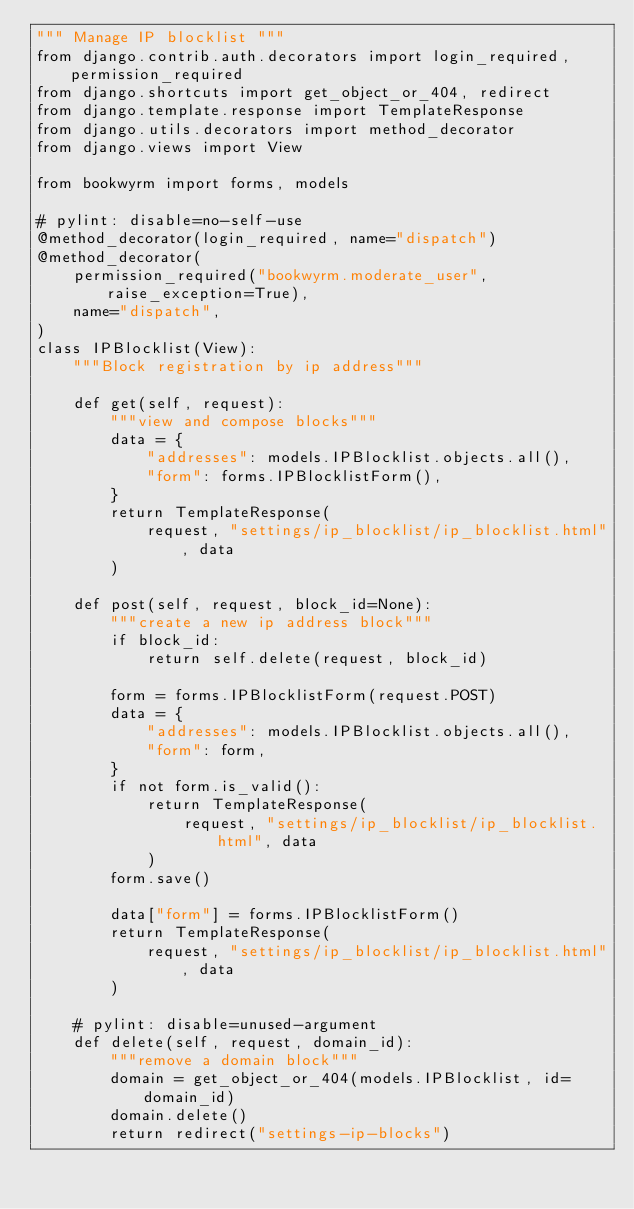Convert code to text. <code><loc_0><loc_0><loc_500><loc_500><_Python_>""" Manage IP blocklist """
from django.contrib.auth.decorators import login_required, permission_required
from django.shortcuts import get_object_or_404, redirect
from django.template.response import TemplateResponse
from django.utils.decorators import method_decorator
from django.views import View

from bookwyrm import forms, models

# pylint: disable=no-self-use
@method_decorator(login_required, name="dispatch")
@method_decorator(
    permission_required("bookwyrm.moderate_user", raise_exception=True),
    name="dispatch",
)
class IPBlocklist(View):
    """Block registration by ip address"""

    def get(self, request):
        """view and compose blocks"""
        data = {
            "addresses": models.IPBlocklist.objects.all(),
            "form": forms.IPBlocklistForm(),
        }
        return TemplateResponse(
            request, "settings/ip_blocklist/ip_blocklist.html", data
        )

    def post(self, request, block_id=None):
        """create a new ip address block"""
        if block_id:
            return self.delete(request, block_id)

        form = forms.IPBlocklistForm(request.POST)
        data = {
            "addresses": models.IPBlocklist.objects.all(),
            "form": form,
        }
        if not form.is_valid():
            return TemplateResponse(
                request, "settings/ip_blocklist/ip_blocklist.html", data
            )
        form.save()

        data["form"] = forms.IPBlocklistForm()
        return TemplateResponse(
            request, "settings/ip_blocklist/ip_blocklist.html", data
        )

    # pylint: disable=unused-argument
    def delete(self, request, domain_id):
        """remove a domain block"""
        domain = get_object_or_404(models.IPBlocklist, id=domain_id)
        domain.delete()
        return redirect("settings-ip-blocks")
</code> 